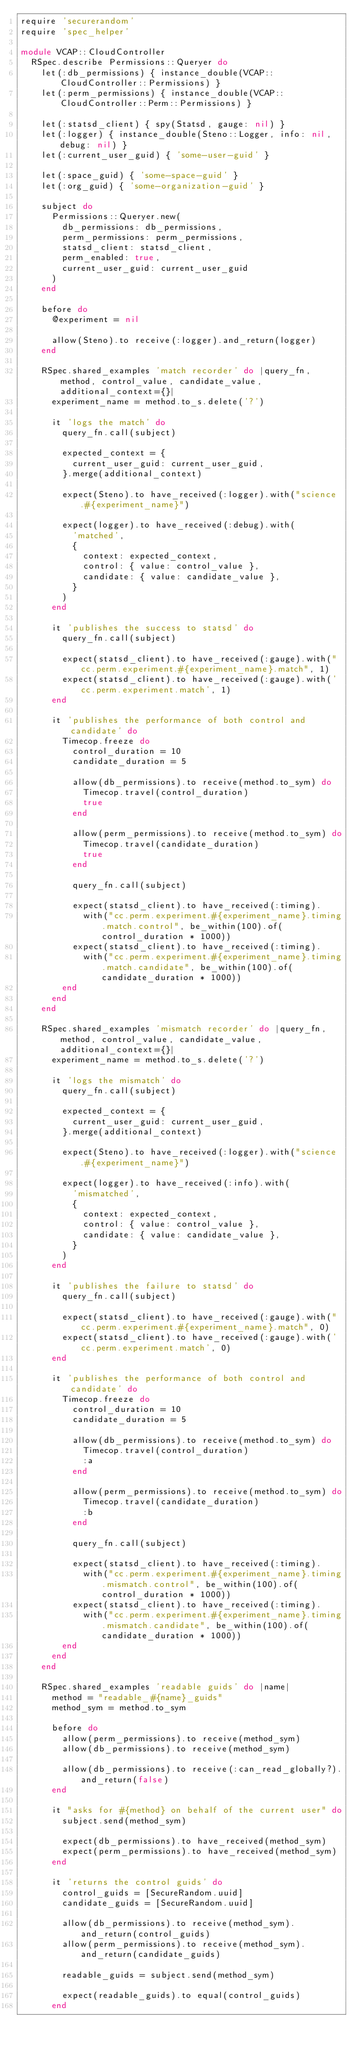Convert code to text. <code><loc_0><loc_0><loc_500><loc_500><_Ruby_>require 'securerandom'
require 'spec_helper'

module VCAP::CloudController
  RSpec.describe Permissions::Queryer do
    let(:db_permissions) { instance_double(VCAP::CloudController::Permissions) }
    let(:perm_permissions) { instance_double(VCAP::CloudController::Perm::Permissions) }

    let(:statsd_client) { spy(Statsd, gauge: nil) }
    let(:logger) { instance_double(Steno::Logger, info: nil, debug: nil) }
    let(:current_user_guid) { 'some-user-guid' }

    let(:space_guid) { 'some-space-guid' }
    let(:org_guid) { 'some-organization-guid' }

    subject do
      Permissions::Queryer.new(
        db_permissions: db_permissions,
        perm_permissions: perm_permissions,
        statsd_client: statsd_client,
        perm_enabled: true,
        current_user_guid: current_user_guid
      )
    end

    before do
      @experiment = nil

      allow(Steno).to receive(:logger).and_return(logger)
    end

    RSpec.shared_examples 'match recorder' do |query_fn, method, control_value, candidate_value, additional_context={}|
      experiment_name = method.to_s.delete('?')

      it 'logs the match' do
        query_fn.call(subject)

        expected_context = {
          current_user_guid: current_user_guid,
        }.merge(additional_context)

        expect(Steno).to have_received(:logger).with("science.#{experiment_name}")

        expect(logger).to have_received(:debug).with(
          'matched',
          {
            context: expected_context,
            control: { value: control_value },
            candidate: { value: candidate_value },
          }
        )
      end

      it 'publishes the success to statsd' do
        query_fn.call(subject)

        expect(statsd_client).to have_received(:gauge).with("cc.perm.experiment.#{experiment_name}.match", 1)
        expect(statsd_client).to have_received(:gauge).with('cc.perm.experiment.match', 1)
      end

      it 'publishes the performance of both control and candidate' do
        Timecop.freeze do
          control_duration = 10
          candidate_duration = 5

          allow(db_permissions).to receive(method.to_sym) do
            Timecop.travel(control_duration)
            true
          end

          allow(perm_permissions).to receive(method.to_sym) do
            Timecop.travel(candidate_duration)
            true
          end

          query_fn.call(subject)

          expect(statsd_client).to have_received(:timing).
            with("cc.perm.experiment.#{experiment_name}.timing.match.control", be_within(100).of(control_duration * 1000))
          expect(statsd_client).to have_received(:timing).
            with("cc.perm.experiment.#{experiment_name}.timing.match.candidate", be_within(100).of(candidate_duration * 1000))
        end
      end
    end

    RSpec.shared_examples 'mismatch recorder' do |query_fn, method, control_value, candidate_value, additional_context={}|
      experiment_name = method.to_s.delete('?')

      it 'logs the mismatch' do
        query_fn.call(subject)

        expected_context = {
          current_user_guid: current_user_guid,
        }.merge(additional_context)

        expect(Steno).to have_received(:logger).with("science.#{experiment_name}")

        expect(logger).to have_received(:info).with(
          'mismatched',
          {
            context: expected_context,
            control: { value: control_value },
            candidate: { value: candidate_value },
          }
        )
      end

      it 'publishes the failure to statsd' do
        query_fn.call(subject)

        expect(statsd_client).to have_received(:gauge).with("cc.perm.experiment.#{experiment_name}.match", 0)
        expect(statsd_client).to have_received(:gauge).with('cc.perm.experiment.match', 0)
      end

      it 'publishes the performance of both control and candidate' do
        Timecop.freeze do
          control_duration = 10
          candidate_duration = 5

          allow(db_permissions).to receive(method.to_sym) do
            Timecop.travel(control_duration)
            :a
          end

          allow(perm_permissions).to receive(method.to_sym) do
            Timecop.travel(candidate_duration)
            :b
          end

          query_fn.call(subject)

          expect(statsd_client).to have_received(:timing).
            with("cc.perm.experiment.#{experiment_name}.timing.mismatch.control", be_within(100).of(control_duration * 1000))
          expect(statsd_client).to have_received(:timing).
            with("cc.perm.experiment.#{experiment_name}.timing.mismatch.candidate", be_within(100).of(candidate_duration * 1000))
        end
      end
    end

    RSpec.shared_examples 'readable guids' do |name|
      method = "readable_#{name}_guids"
      method_sym = method.to_sym

      before do
        allow(perm_permissions).to receive(method_sym)
        allow(db_permissions).to receive(method_sym)

        allow(db_permissions).to receive(:can_read_globally?).and_return(false)
      end

      it "asks for #{method} on behalf of the current user" do
        subject.send(method_sym)

        expect(db_permissions).to have_received(method_sym)
        expect(perm_permissions).to have_received(method_sym)
      end

      it 'returns the control guids' do
        control_guids = [SecureRandom.uuid]
        candidate_guids = [SecureRandom.uuid]

        allow(db_permissions).to receive(method_sym).and_return(control_guids)
        allow(perm_permissions).to receive(method_sym).and_return(candidate_guids)

        readable_guids = subject.send(method_sym)

        expect(readable_guids).to equal(control_guids)
      end
</code> 